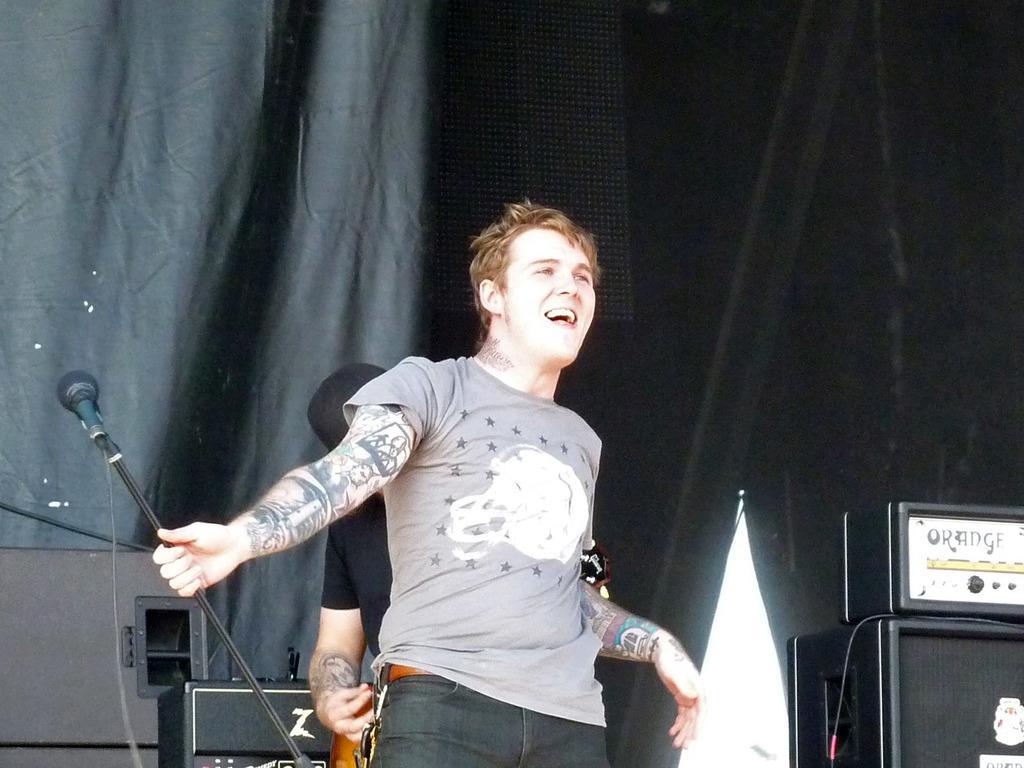Could you give a brief overview of what you see in this image? there is a man standing on stage laughing and holding microphone. Behind the man there is other man standing in black costume adjusting this man's costume and the stage is covered with black color cloth. On the stage there is a sound box placed. 